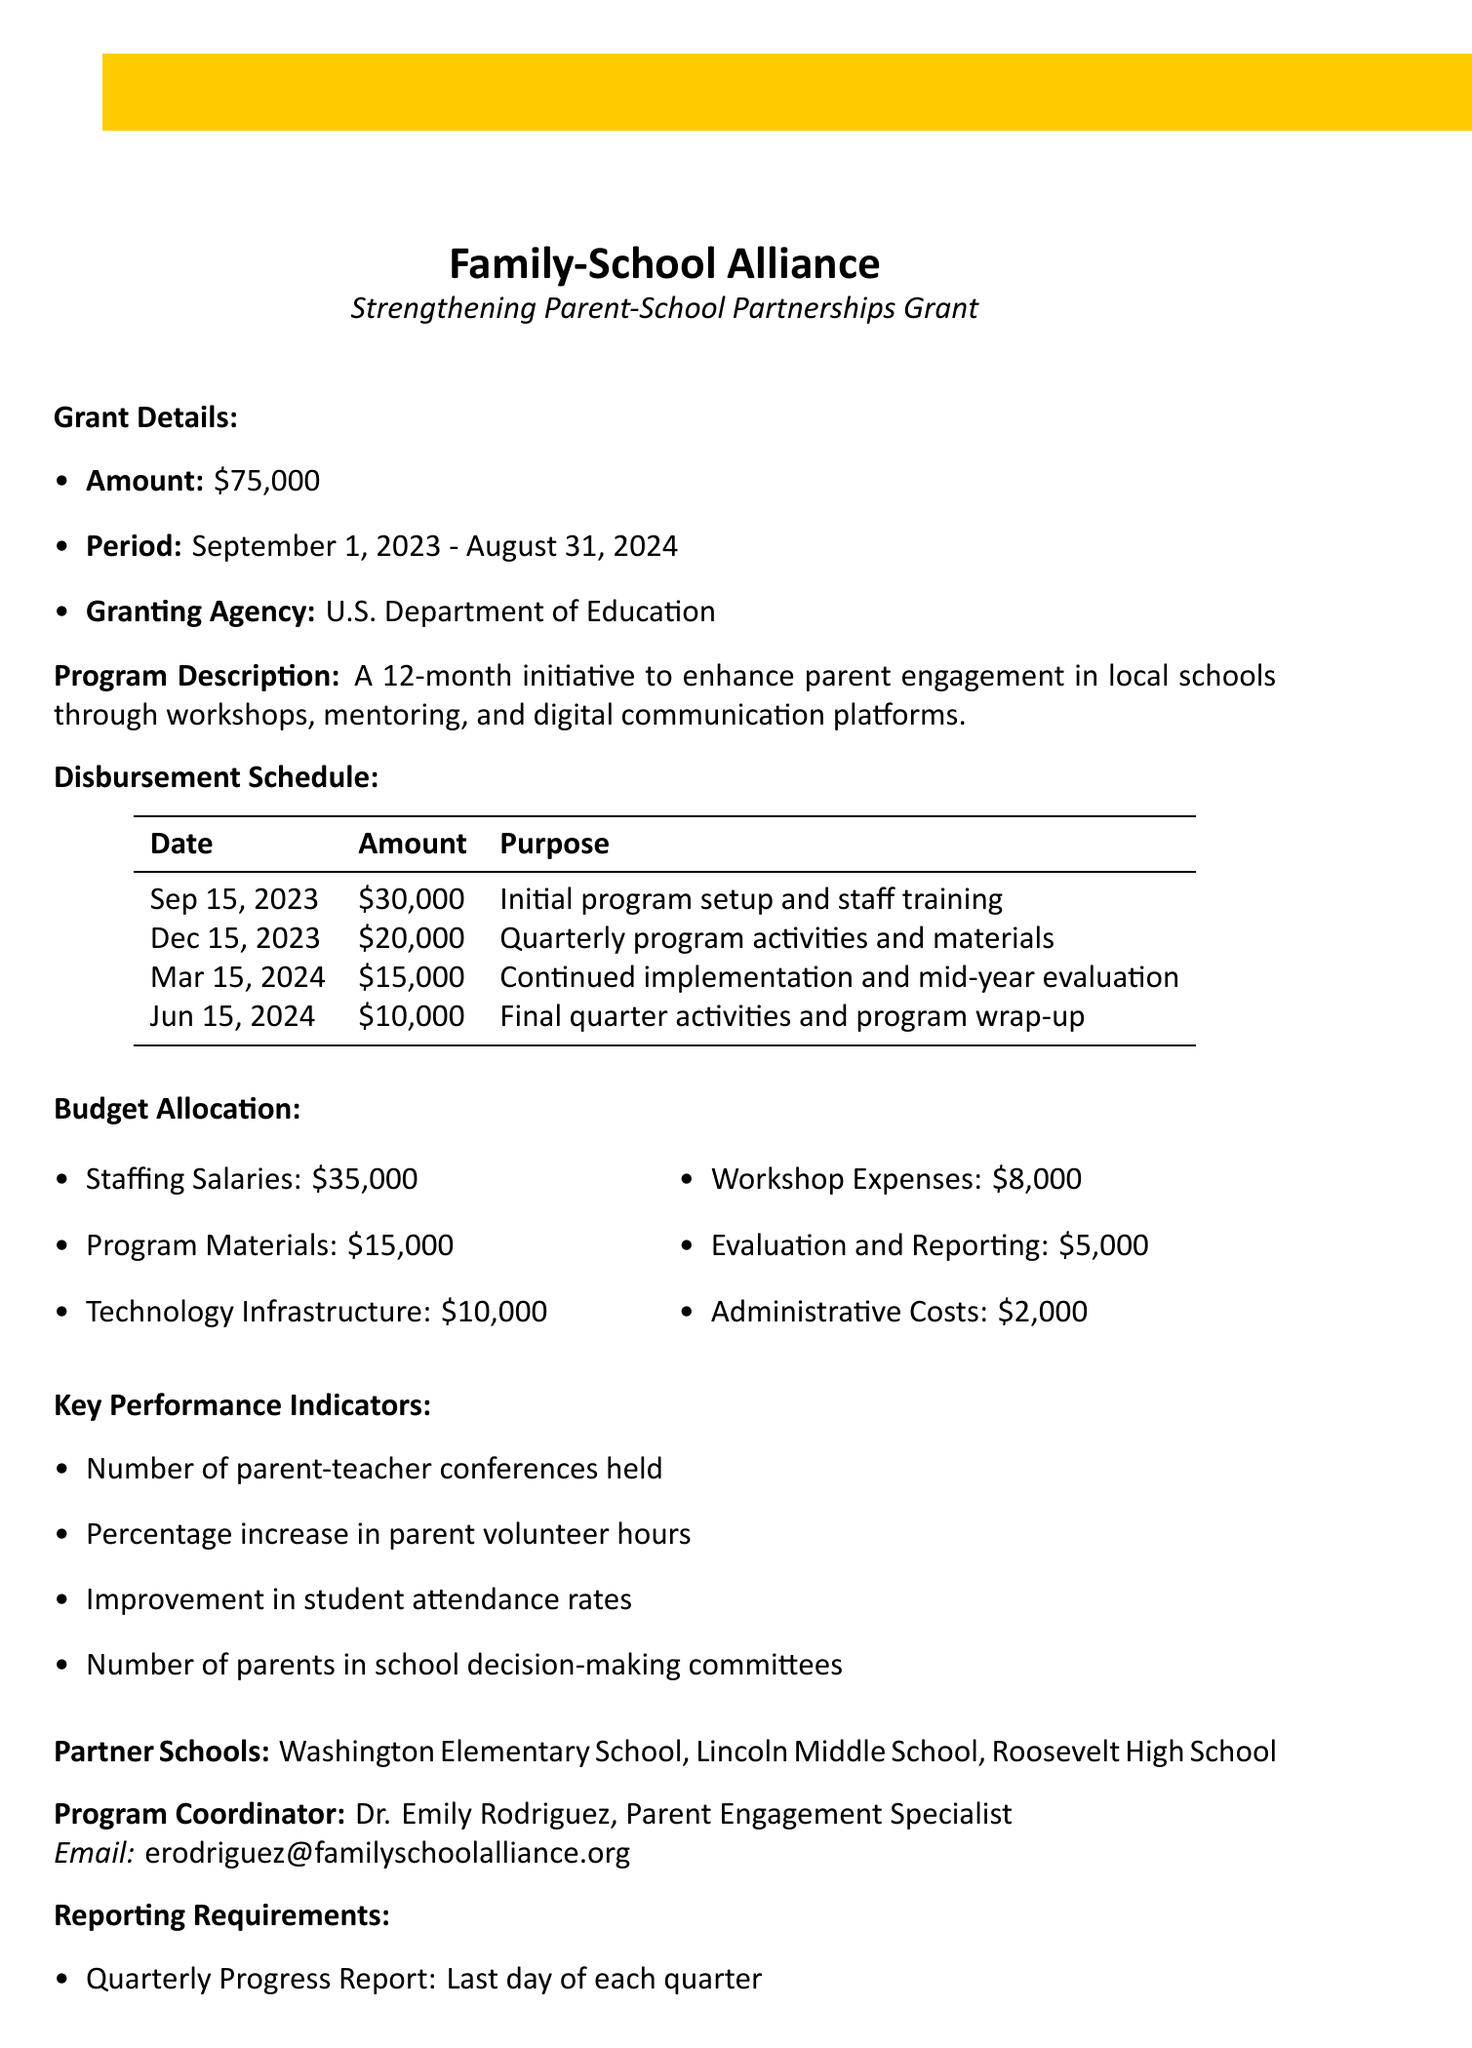What is the name of the organization? The organization name is outlined at the beginning of the document.
Answer: Family-School Alliance What is the total grant amount? The total grant amount is specified in the grant details section.
Answer: $75,000 When does the grant period start? The start date of the grant period is listed in the grant period section.
Answer: September 1, 2023 What is the purpose of the first disbursement? The purpose of the first disbursement is detailed in the disbursement schedule section.
Answer: Initial program setup and staff training How many partner schools are involved in the program? The number of partner schools is mentioned in the partner schools section.
Answer: 3 What is the last date for the final program evaluation report? The due date for the final program evaluation is specified in the reporting requirements section.
Answer: September 30, 2024 Who is the program coordinator? The document includes a specific section naming the program coordinator.
Answer: Dr. Emily Rodriguez What is the budget allocation for workshop expenses? The budget allocation details include specific amounts for various categories, including workshop expenses.
Answer: $8,000 What type of report is due on the last day of each quarter? The reporting requirements section lists the type of report expected.
Answer: Quarterly Progress Report 